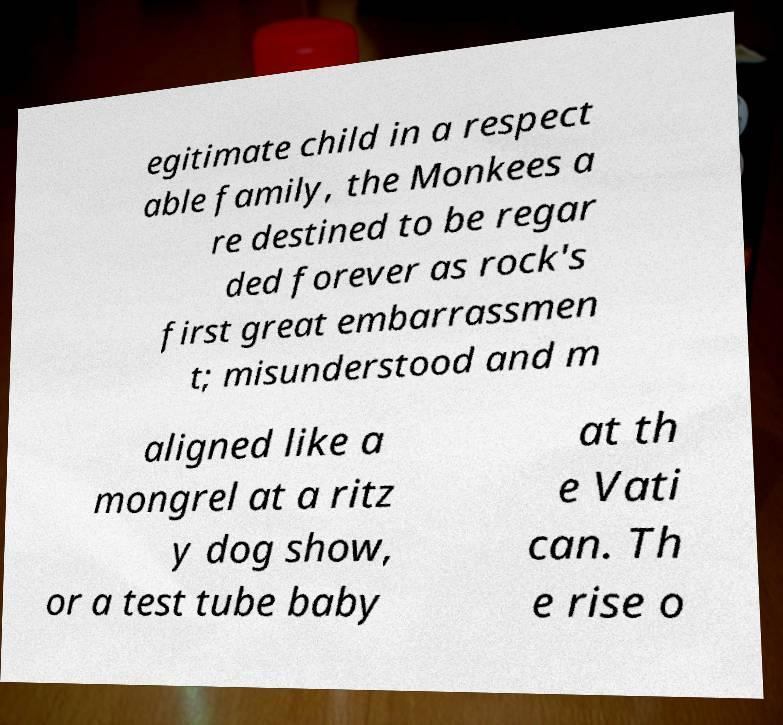Please read and relay the text visible in this image. What does it say? egitimate child in a respect able family, the Monkees a re destined to be regar ded forever as rock's first great embarrassmen t; misunderstood and m aligned like a mongrel at a ritz y dog show, or a test tube baby at th e Vati can. Th e rise o 